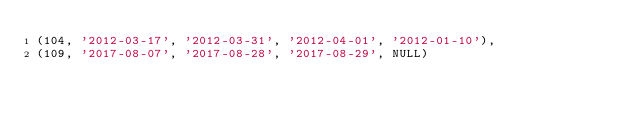<code> <loc_0><loc_0><loc_500><loc_500><_SQL_>(104, '2012-03-17', '2012-03-31', '2012-04-01', '2012-01-10'),
(109, '2017-08-07', '2017-08-28', '2017-08-29', NULL)
</code> 